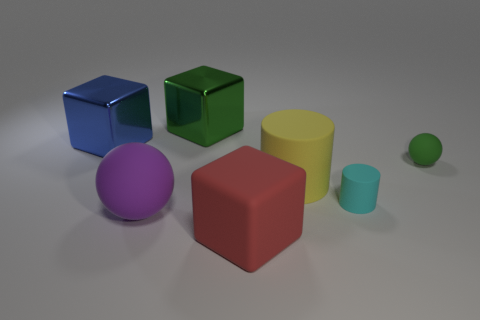Add 2 tiny green metal blocks. How many objects exist? 9 Subtract all matte cubes. How many cubes are left? 2 Subtract 1 cylinders. How many cylinders are left? 1 Subtract all red cylinders. Subtract all gray cubes. How many cylinders are left? 2 Subtract all tiny green rubber spheres. Subtract all big yellow cylinders. How many objects are left? 5 Add 3 red objects. How many red objects are left? 4 Add 1 large blue things. How many large blue things exist? 2 Subtract all green spheres. How many spheres are left? 1 Subtract 0 gray blocks. How many objects are left? 7 Subtract all blocks. How many objects are left? 4 